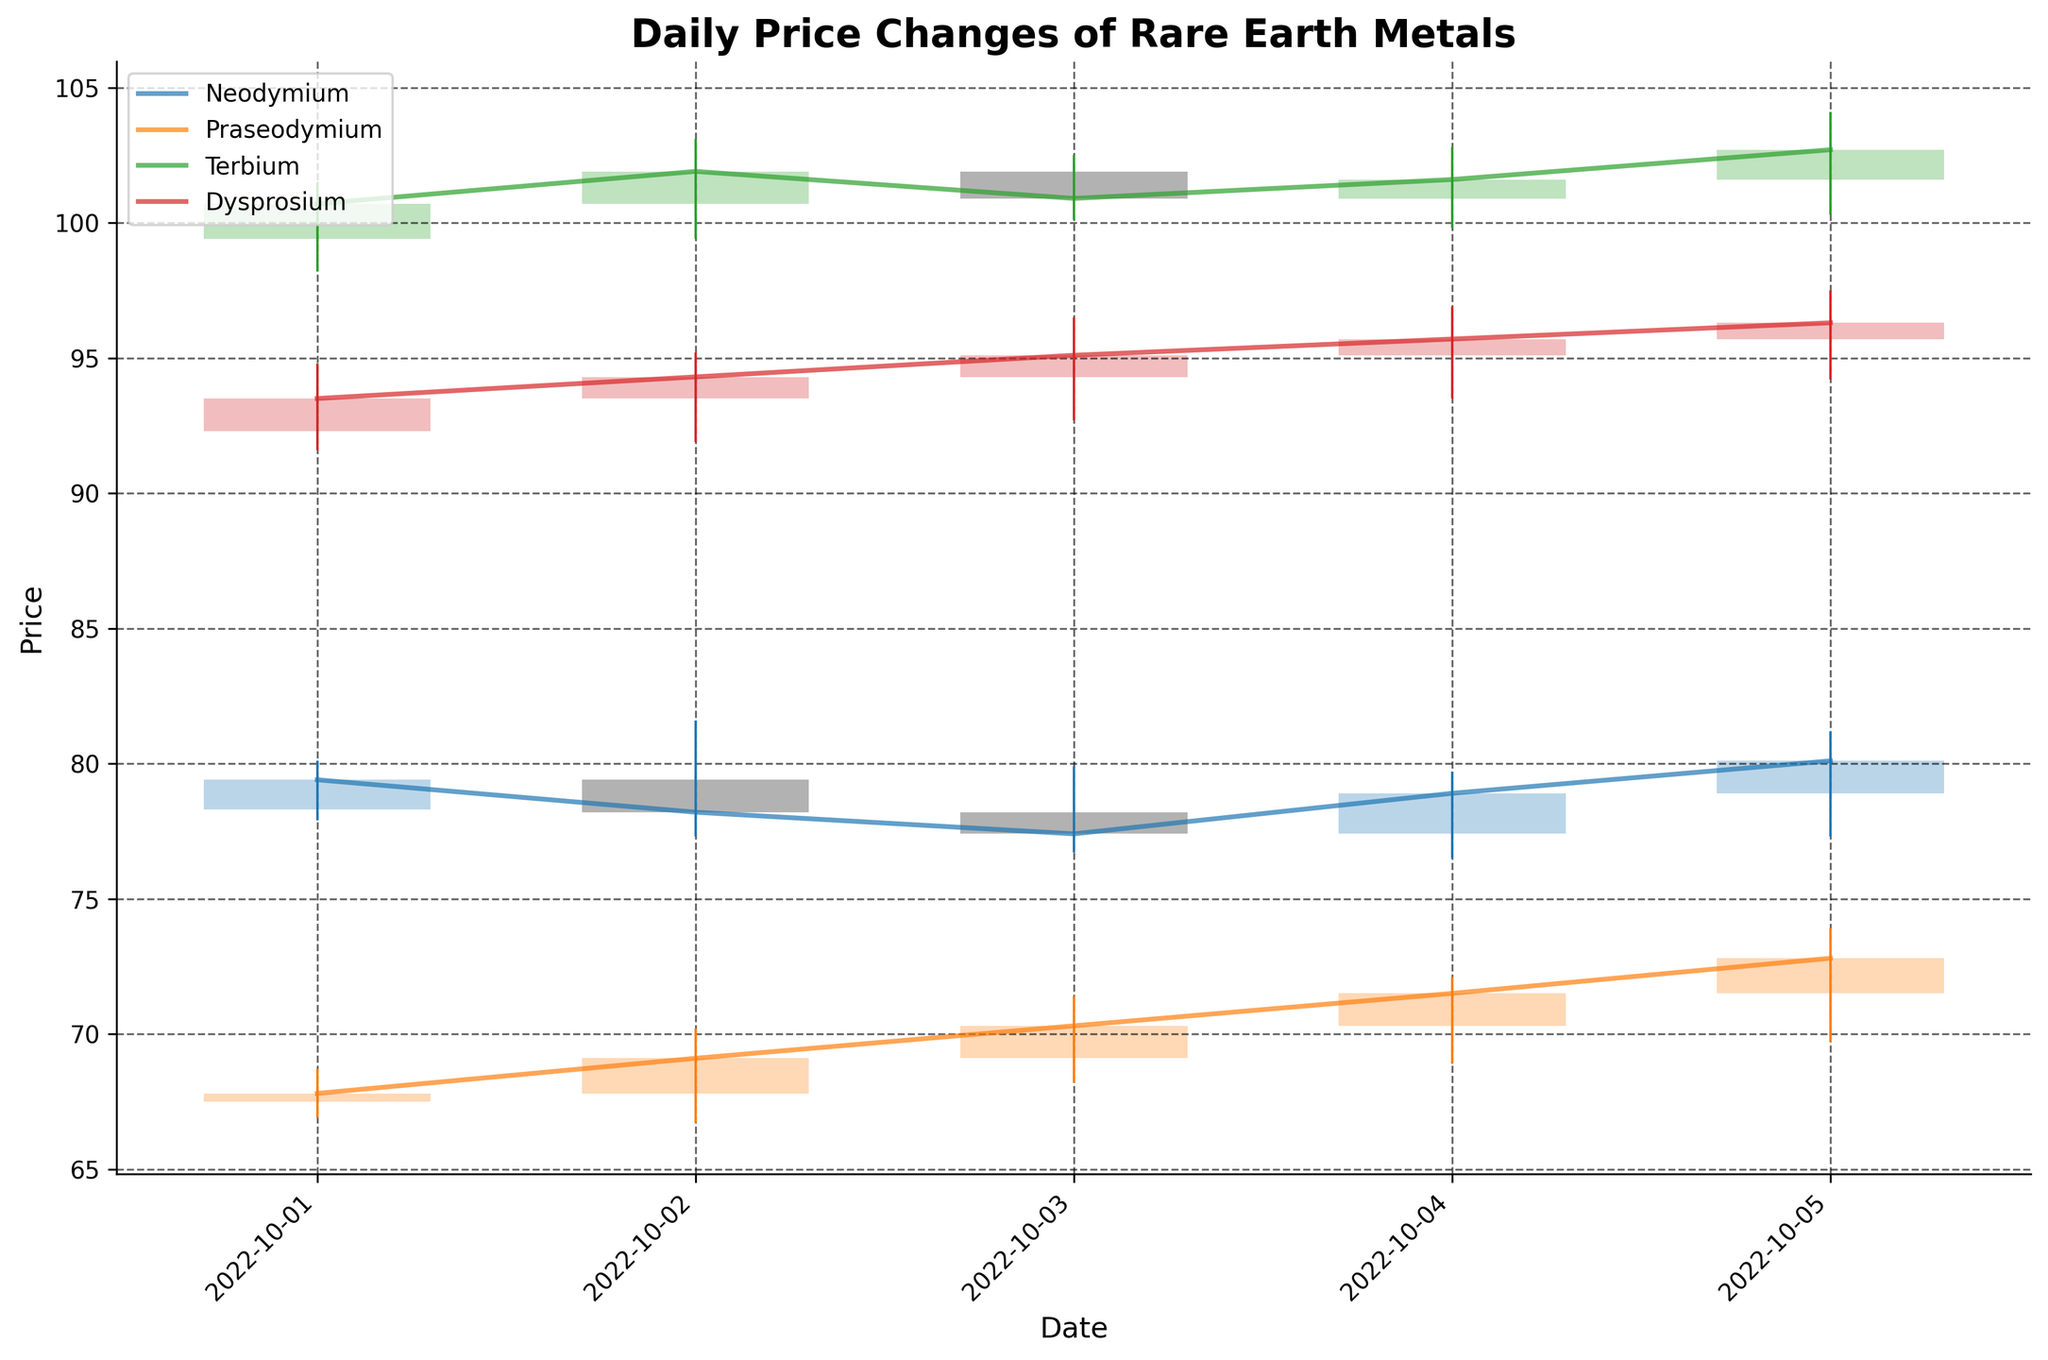What is the title of the figure? The title is usually found at the top of the plot and summarises the content of the figure. It helps provide context for interpreting the data.
Answer: Daily Price Changes of Rare Earth Metals What are the x-axis and y-axis labels on the figure? The x-axis label represents the variable plotted along the horizontal axis, which is the 'Date'. The y-axis label represents the variable plotted along the vertical axis, which is the 'Price'. These labels help in understanding what data the axes are representing.
Answer: Date, Price Which metal had the highest closing price on October 1, 2022? To find this, look at the closing price for each metal on October 1. Terbium's closing price on this date is the highest.
Answer: Terbium On which date did Praseodymium have the lowest price range? To determine this, calculate the range (High - Low) for each date for Praseodymium. The smallest range occurs on October 1, where the range is 68.7 - 66.9 = 1.8.
Answer: October 1, 2022 What was the trend of Dysprosium's closing prices from October 1 to October 5? Observe the closing prices for Dysprosium over the specified dates: it started at 93.5 and progressively increased to 96.3. This indicates an upward trend.
Answer: Upward trend Which metal exhibited the largest daily price swing on October 3, 2022? The price swing is determined by subtracting the Low from the High for each metal on October 3. Terbium has the largest swing with 102.5 - 100.1 = 2.4.
Answer: Terbium Compare the trend of Neodymium and Praseodymium prices over the five days. Which metal showed more consistency in its closing prices? Look at the closing prices for both metals. Neodymium fluctuates between 77.4 and 80.1, while Praseodymium fluctuates between 67.8 and 72.8. Neodymium shows less fluctuation.
Answer: Neodymium Which day had the highest overall combined closing prices for all metals? Add up the closing prices for each metal for every date, then compare to find the highest sum. October 2 has the highest: 78.2 + 69.1 + 101.9 + 94.3 = 343.5.
Answer: October 2, 2022 Did any metal close lower than its opening price on October 4, 2022? Compare the open and close prices for each metal on October 4. Neodymium closed higher (78.9 > 77.4). Praseodymium closed higher (71.5 > 70.3). Terbium closed higher (101.6 > 100.9). Dysprosium also closed higher (95.7 > 95.1). Hence, no metal closed lower than it opened.
Answer: No 